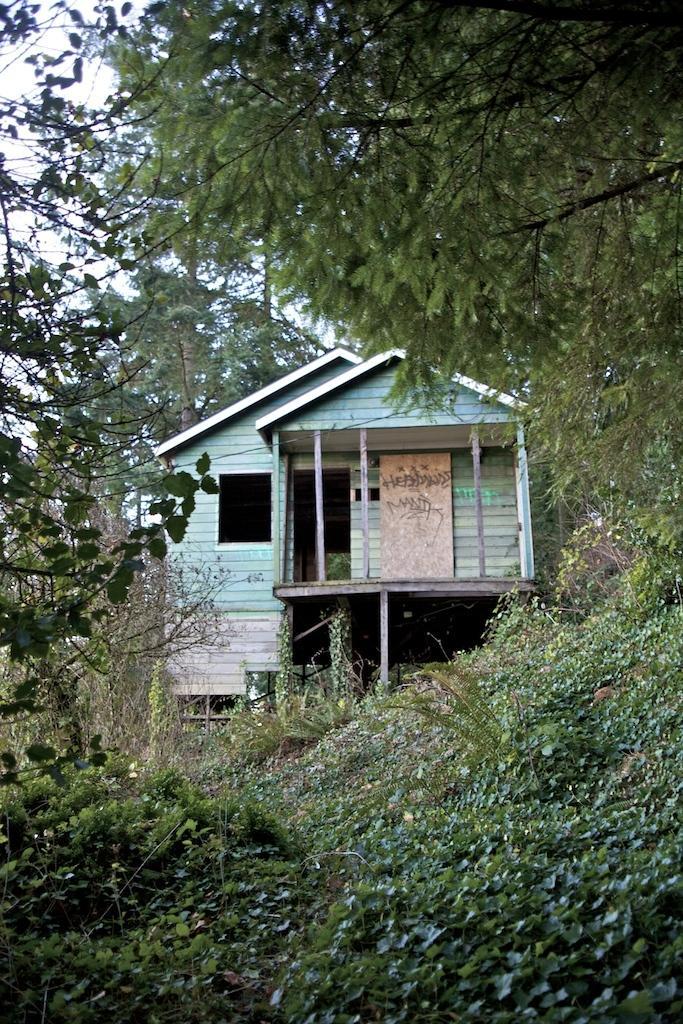Please provide a concise description of this image. In this image, we can see some plants and trees. There is a shelter house in the middle of the image. 